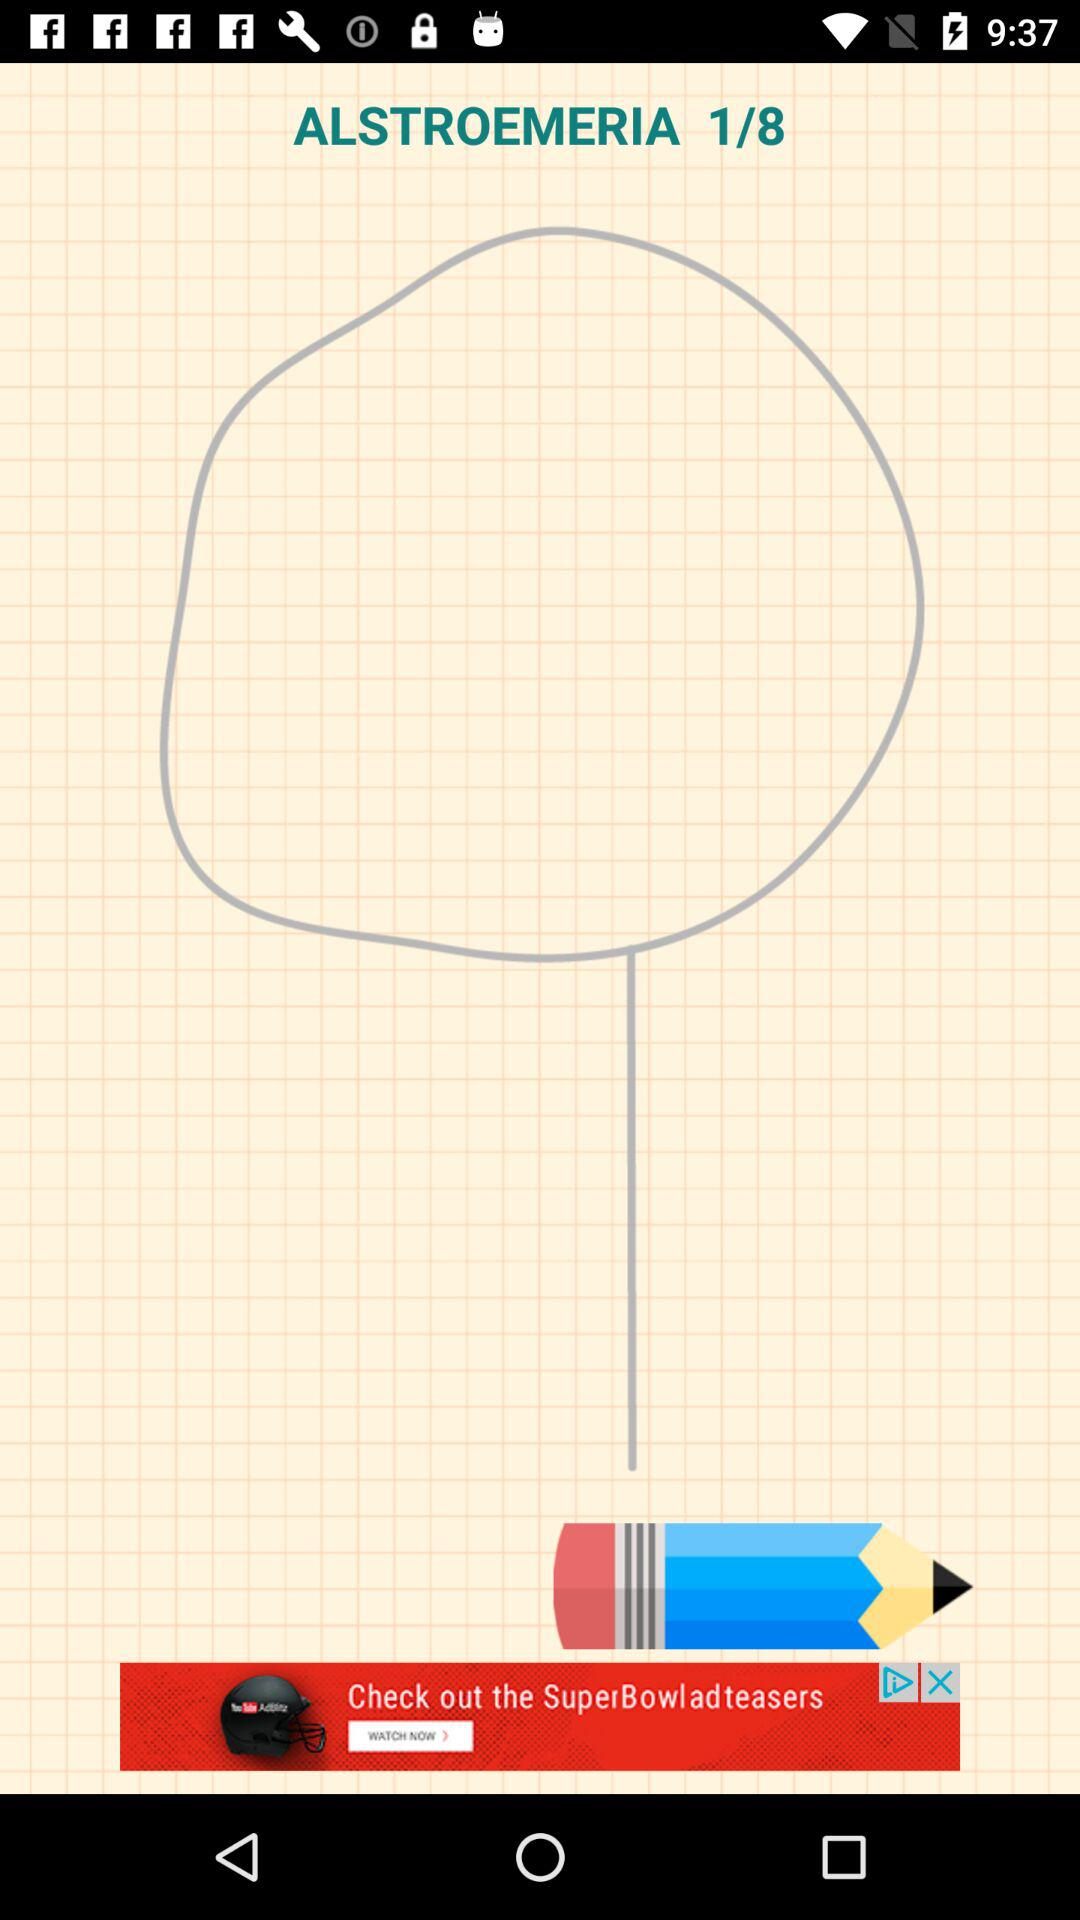What is the total number of alstroemeria? The total number of alstroemeria is 8. 